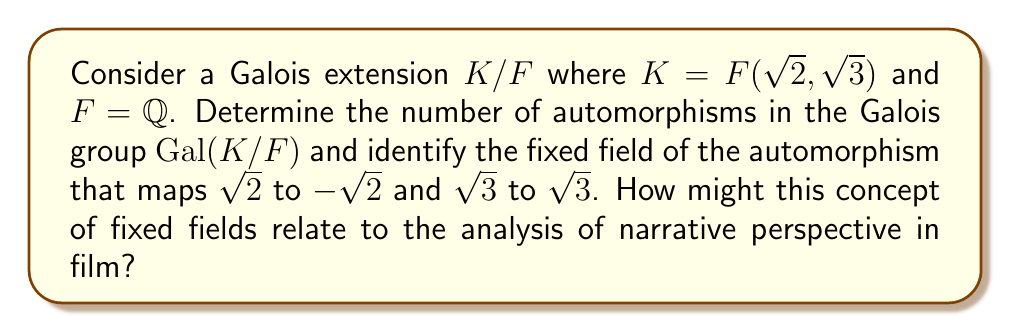Teach me how to tackle this problem. 1) First, let's determine the Galois group $Gal(K/F)$:
   - $K = F(\sqrt{2}, \sqrt{3})$ is a splitting field over $\mathbb{Q}$ for $(x^2-2)(x^2-3)$
   - $[K:F] = 4$ as it's a composition of two quadratic extensions

2) The automorphisms in $Gal(K/F)$ are:
   $\sigma_1: \sqrt{2} \mapsto \sqrt{2}, \sqrt{3} \mapsto \sqrt{3}$ (identity)
   $\sigma_2: \sqrt{2} \mapsto -\sqrt{2}, \sqrt{3} \mapsto \sqrt{3}$
   $\sigma_3: \sqrt{2} \mapsto \sqrt{2}, \sqrt{3} \mapsto -\sqrt{3}$
   $\sigma_4: \sqrt{2} \mapsto -\sqrt{2}, \sqrt{3} \mapsto -\sqrt{3}$

3) The number of automorphisms is 4, which is equal to $[K:F]$ as expected for a Galois extension.

4) To find the fixed field of $\sigma_2$:
   - Elements fixed by $\sigma_2$ are of the form $a + b\sqrt{3}$ where $a,b \in \mathbb{Q}$
   - This is because $\sigma_2(\sqrt{3}) = \sqrt{3}$ but $\sigma_2(\sqrt{2}) = -\sqrt{2}$

5) Therefore, the fixed field of $\sigma_2$ is $\mathbb{Q}(\sqrt{3})$

6) Relating to film analysis:
   The concept of fixed fields in Galois theory can be analogous to the perspective or "lens" through which a narrative is presented in film. Just as certain elements remain "fixed" under an automorphism, certain aspects of a story remain constant despite shifts in narrative perspective. This could be used to analyze how different characters' viewpoints affect the storytelling while core elements of the plot remain unchanged.
Answer: 4 automorphisms; Fixed field of $\sigma_2$ is $\mathbb{Q}(\sqrt{3})$ 